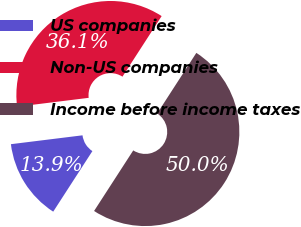Convert chart. <chart><loc_0><loc_0><loc_500><loc_500><pie_chart><fcel>US companies<fcel>Non-US companies<fcel>Income before income taxes<nl><fcel>13.9%<fcel>36.1%<fcel>50.0%<nl></chart> 